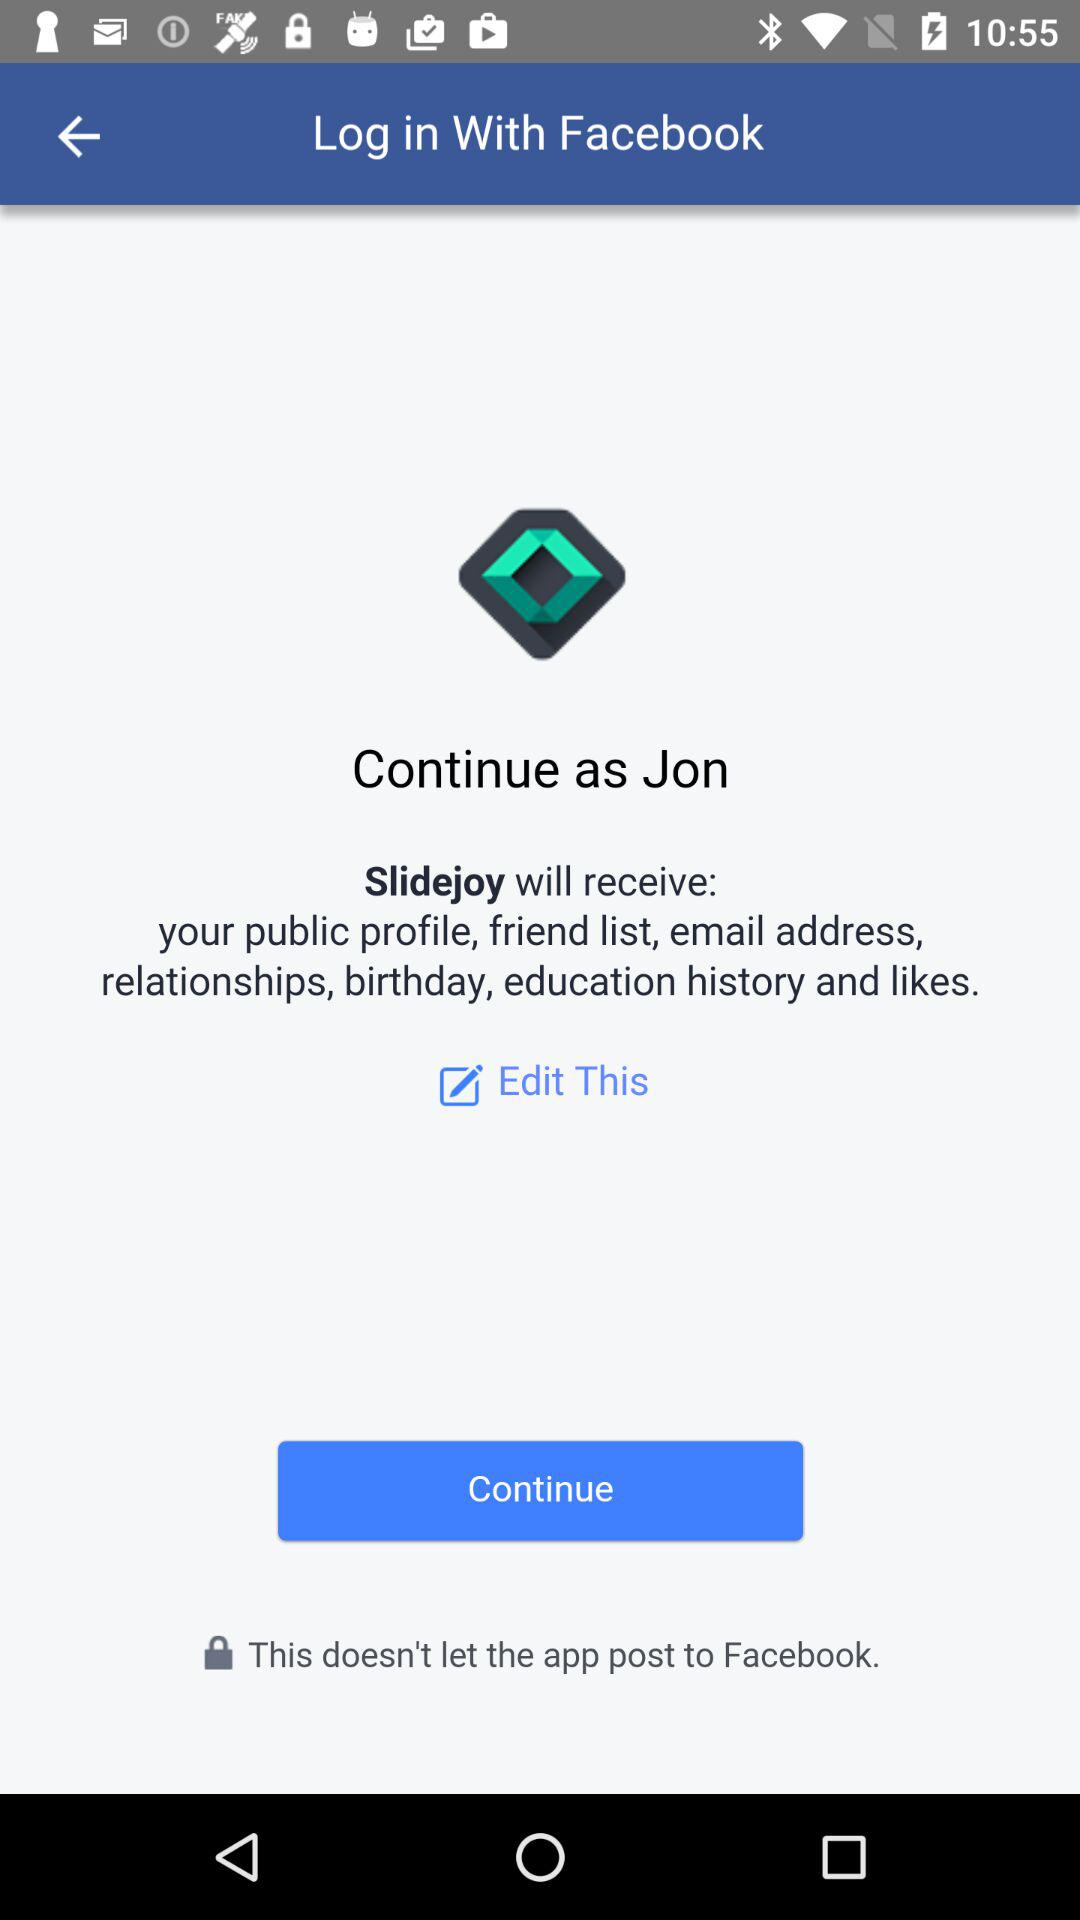What application is asking for permission? The application asking for permission is "Slidejoy". 